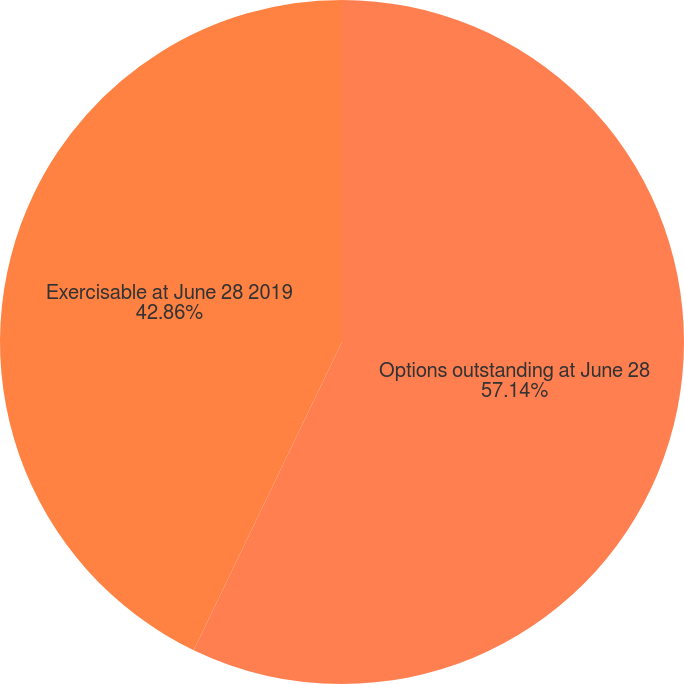Convert chart. <chart><loc_0><loc_0><loc_500><loc_500><pie_chart><fcel>Options outstanding at June 28<fcel>Exercisable at June 28 2019<nl><fcel>57.14%<fcel>42.86%<nl></chart> 